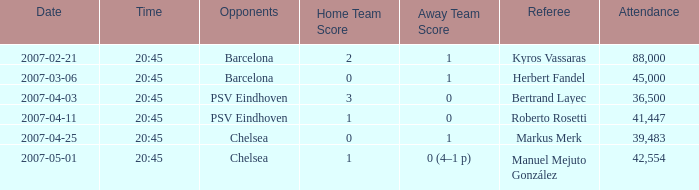What was the outcome of the game that began at 20:45 on 2007-03-06? 0–1. 